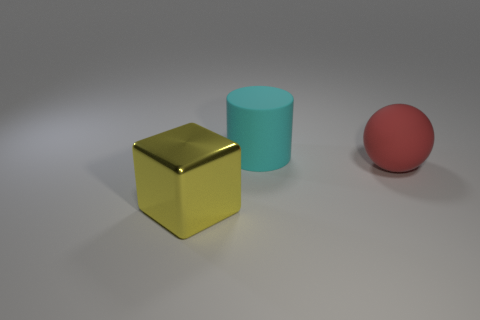Add 2 tiny brown things. How many objects exist? 5 Subtract all cylinders. How many objects are left? 2 Subtract 0 blue spheres. How many objects are left? 3 Subtract all rubber spheres. Subtract all big rubber balls. How many objects are left? 1 Add 1 large blocks. How many large blocks are left? 2 Add 1 small gray cylinders. How many small gray cylinders exist? 1 